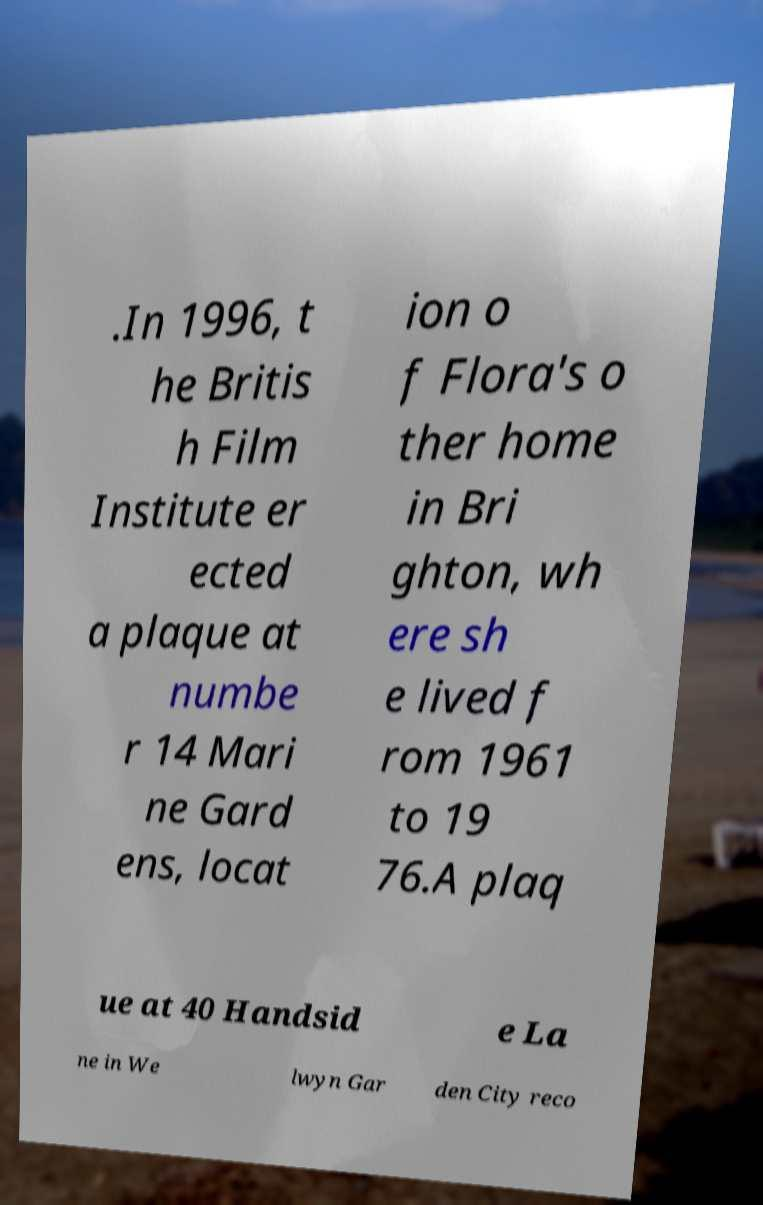There's text embedded in this image that I need extracted. Can you transcribe it verbatim? .In 1996, t he Britis h Film Institute er ected a plaque at numbe r 14 Mari ne Gard ens, locat ion o f Flora's o ther home in Bri ghton, wh ere sh e lived f rom 1961 to 19 76.A plaq ue at 40 Handsid e La ne in We lwyn Gar den City reco 